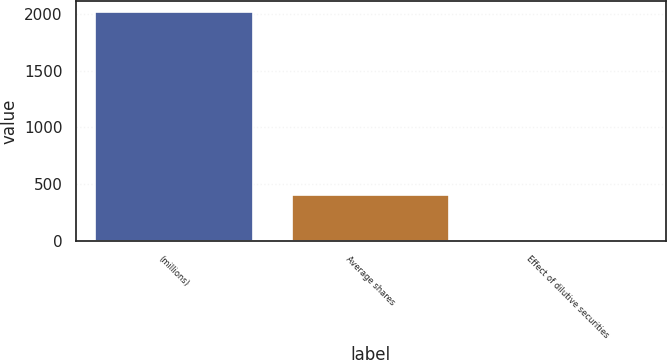Convert chart. <chart><loc_0><loc_0><loc_500><loc_500><bar_chart><fcel>(millions)<fcel>Average shares<fcel>Effect of dilutive securities<nl><fcel>2013<fcel>403.8<fcel>1.5<nl></chart> 